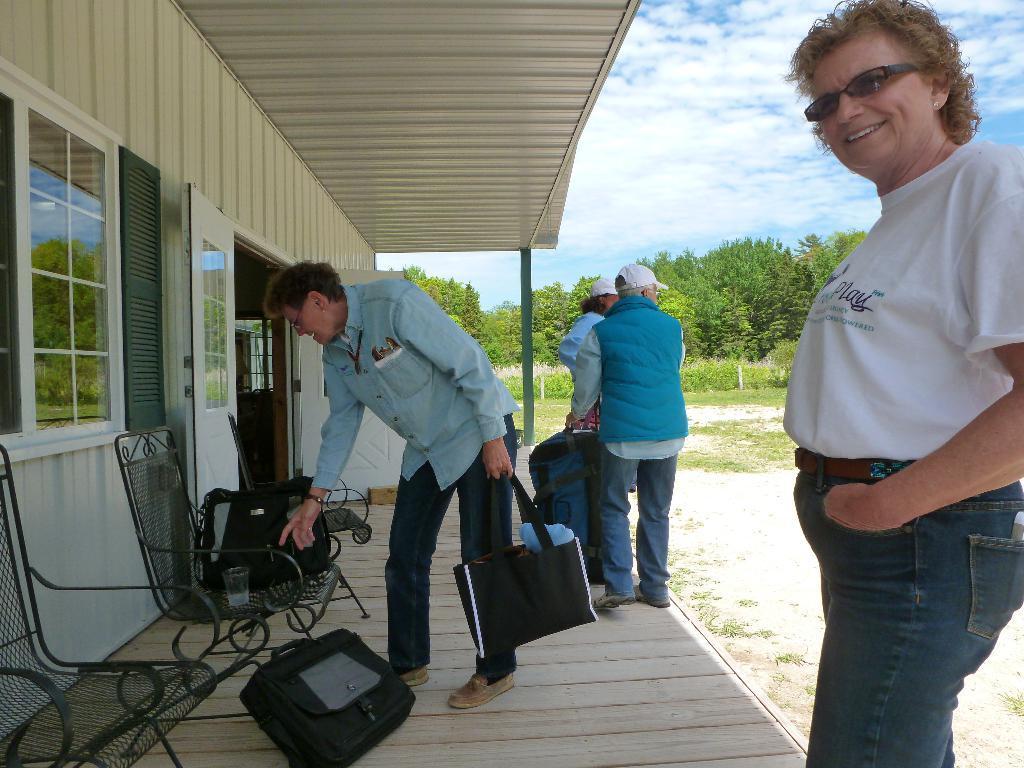How would you summarize this image in a sentence or two? There are people standing and this man holding bag and we can see chairs. We can see bag and glass on this chair and we can see wall, door and windows and we can see bag on surface. Background we can see trees,grass and sky. 